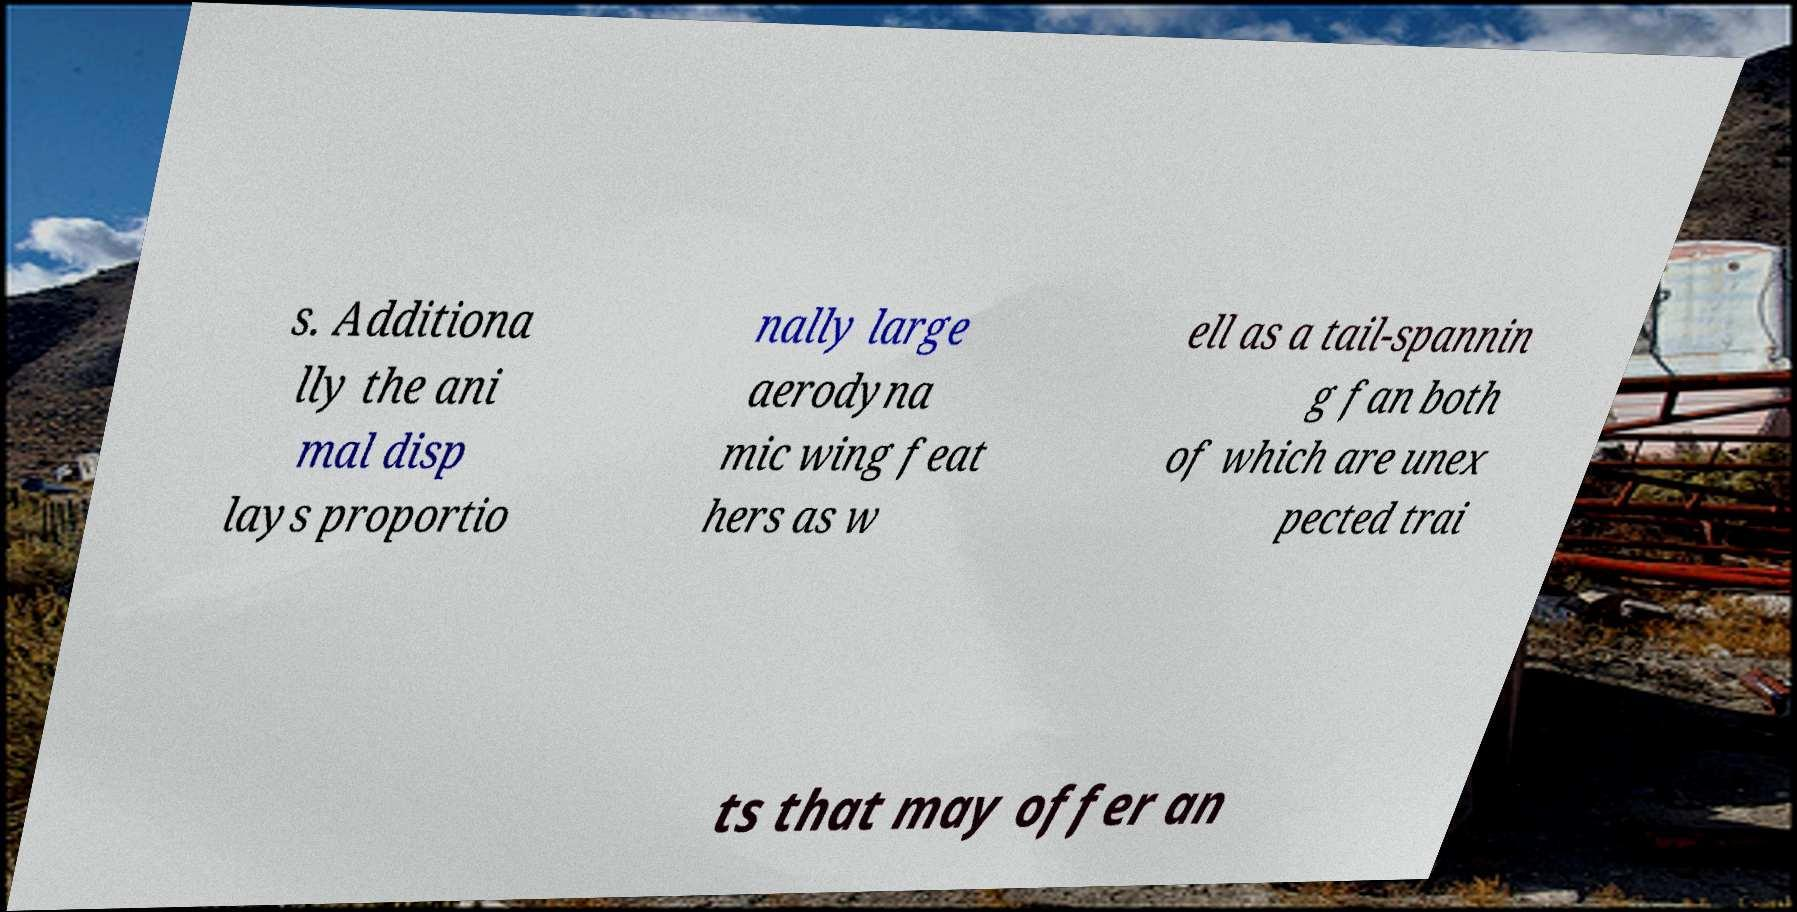Could you extract and type out the text from this image? s. Additiona lly the ani mal disp lays proportio nally large aerodyna mic wing feat hers as w ell as a tail-spannin g fan both of which are unex pected trai ts that may offer an 